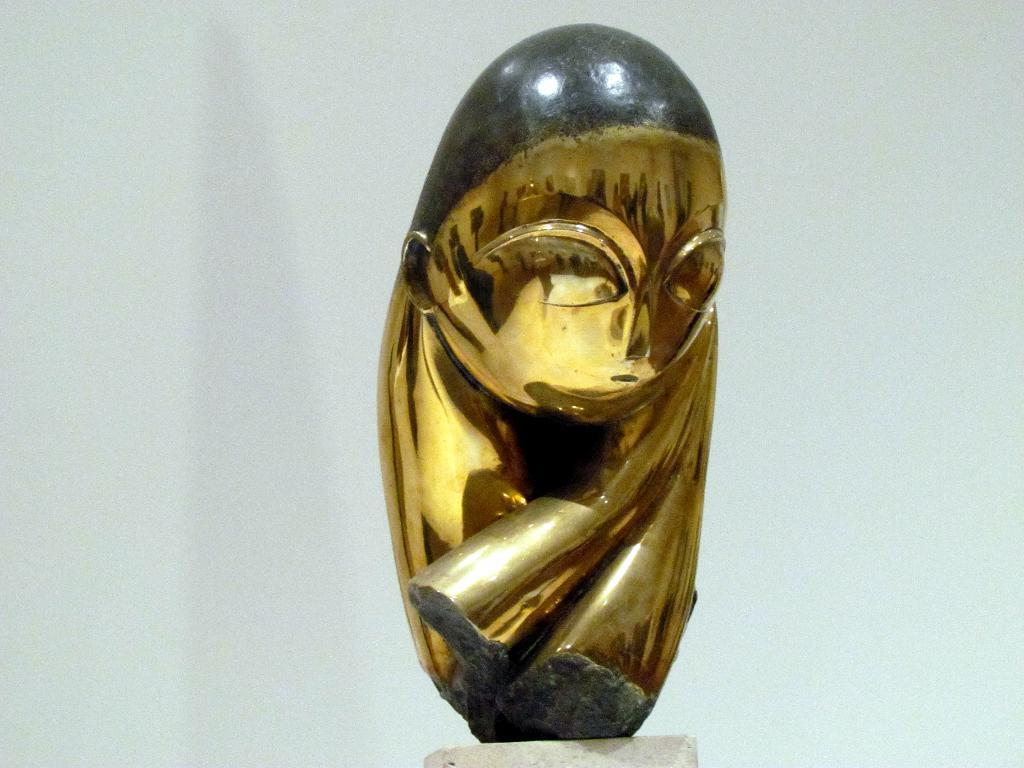What is the main subject of the image? There is a statue in the image. Can you describe the statue's surroundings? There is a wall visible in the image, specifically on the backside of the statue. What type of attack is being carried out by the bears in the image? There are no bears present in the image, so no attack can be observed. What country is depicted in the image? The image does not depict a specific country; it features a statue and a wall. 